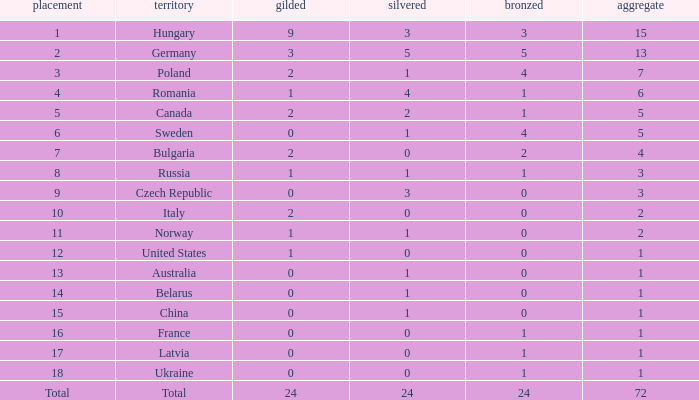What average silver has belarus as the nation, with a total less than 1? None. 